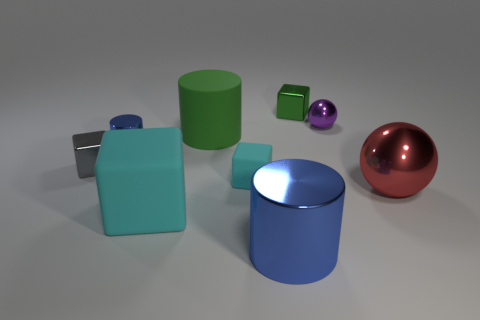Are there any green objects that have the same shape as the big blue metal thing?
Your response must be concise. Yes. How many other things are the same color as the large sphere?
Make the answer very short. 0. Are there fewer balls that are behind the big red sphere than metallic blocks?
Your answer should be very brief. Yes. How many small metal cubes are there?
Your answer should be very brief. 2. How many green cubes are made of the same material as the big green cylinder?
Keep it short and to the point. 0. What number of things are blue metallic cylinders on the left side of the big rubber block or large yellow cylinders?
Provide a short and direct response. 1. Are there fewer small blue cylinders that are to the left of the small gray object than gray metal blocks that are in front of the purple metal thing?
Your answer should be compact. Yes. There is a green metal thing; are there any cubes in front of it?
Keep it short and to the point. Yes. How many things are either blue things that are behind the big cube or metallic cylinders behind the large metal sphere?
Keep it short and to the point. 1. How many shiny things have the same color as the large metallic cylinder?
Your answer should be very brief. 1. 